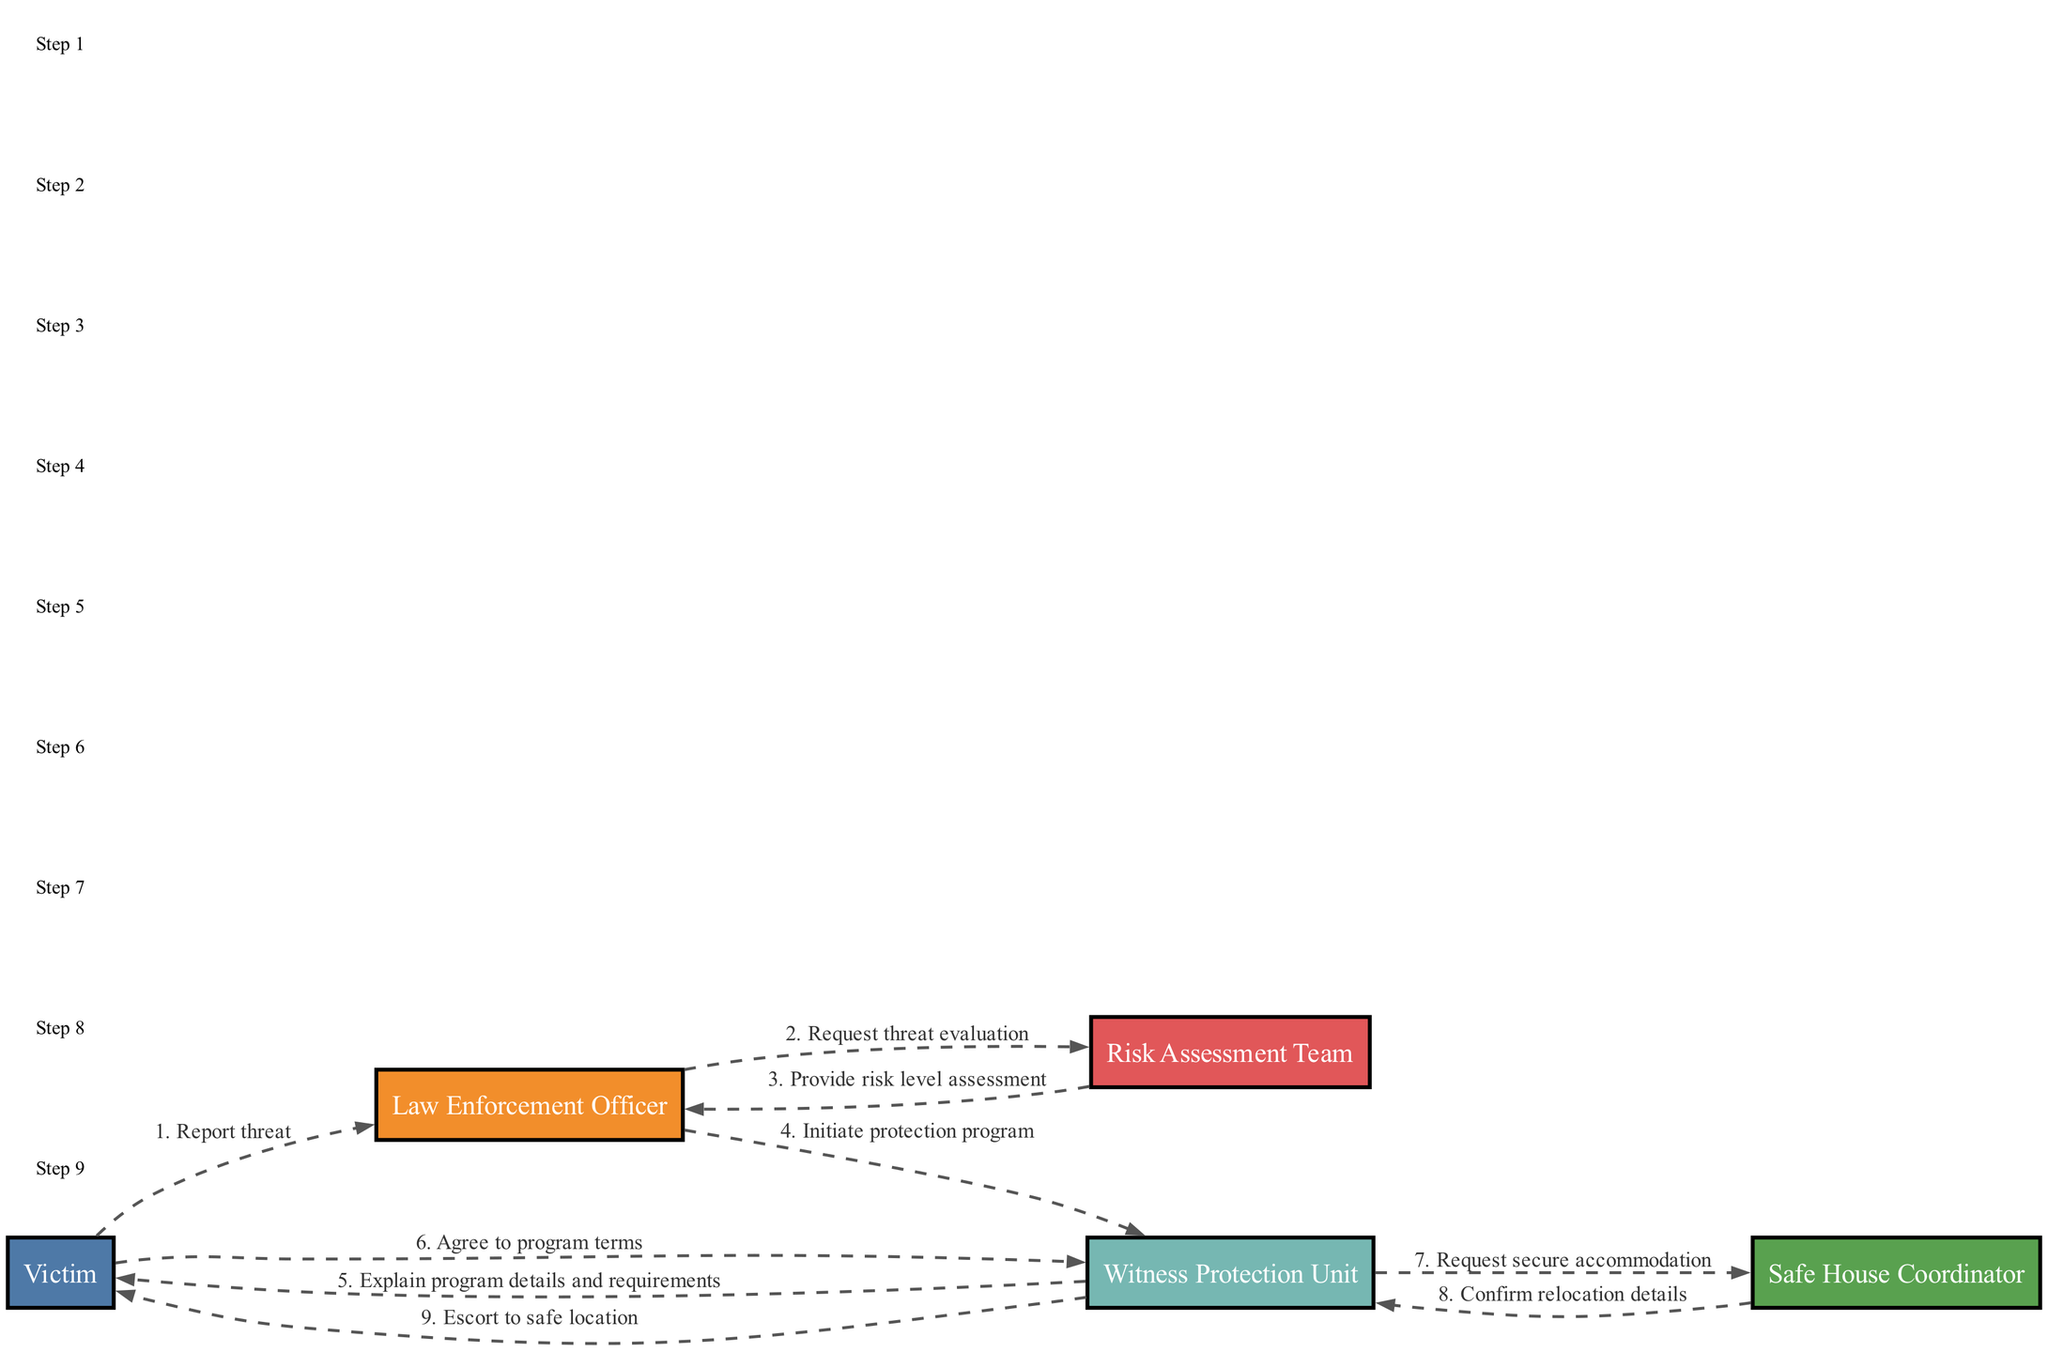What is the first action taken by the victim? The diagram shows that the first action is initiated by the victim who reports a threat to the law enforcement officer. This is the starting point of the sequence.
Answer: Report threat How many actors are involved in the sequence? By counting the distinct entities (nodes) in the diagram, we find five actors: Victim, Law Enforcement Officer, Risk Assessment Team, Witness Protection Unit, and Safe House Coordinator.
Answer: Five What message does the Risk Assessment Team send to the Law Enforcement Officer? The sequence indicates that the Risk Assessment Team provides a risk level assessment to the Law Enforcement Officer. This is a crucial step that informs the next action.
Answer: Provide risk level assessment What does the Witness Protection Unit explain to the victim? The diagram shows that the Witness Protection Unit explains the program details and requirements to the victim as part of the implementation sequence. This is an informative step within the process.
Answer: Explain program details and requirements What happens after the Law Enforcement Officer initiates the protection program? Upon initiation of the protection program by the Law Enforcement Officer, the next step involves the Witness Protection Unit communicating with the victim to explain the program details and requirements. This illustrates the direct sequential flow of actions.
Answer: Explain program details and requirements What is requested by the Witness Protection Unit from the Safe House Coordinator? According to the diagram, the Witness Protection Unit sends a request for secure accommodation to the Safe House Coordinator, indicating a logistical step in the plan for victim relocation.
Answer: Request secure accommodation How does the communication flow from the Safe House Coordinator back to the Witness Protection Unit? The Safe House Coordinator responds to the Witness Protection Unit by confirming the relocation details, illustrating a feedback loop in the communication between these two entities within the operation.
Answer: Confirm relocation details What step follows after the victim agrees to the program terms? After the victim agrees to the program terms, the Witness Protection Unit requests secure accommodation from the Safe House Coordinator, demonstrating a shift from agreement to action in the process.
Answer: Request secure accommodation 